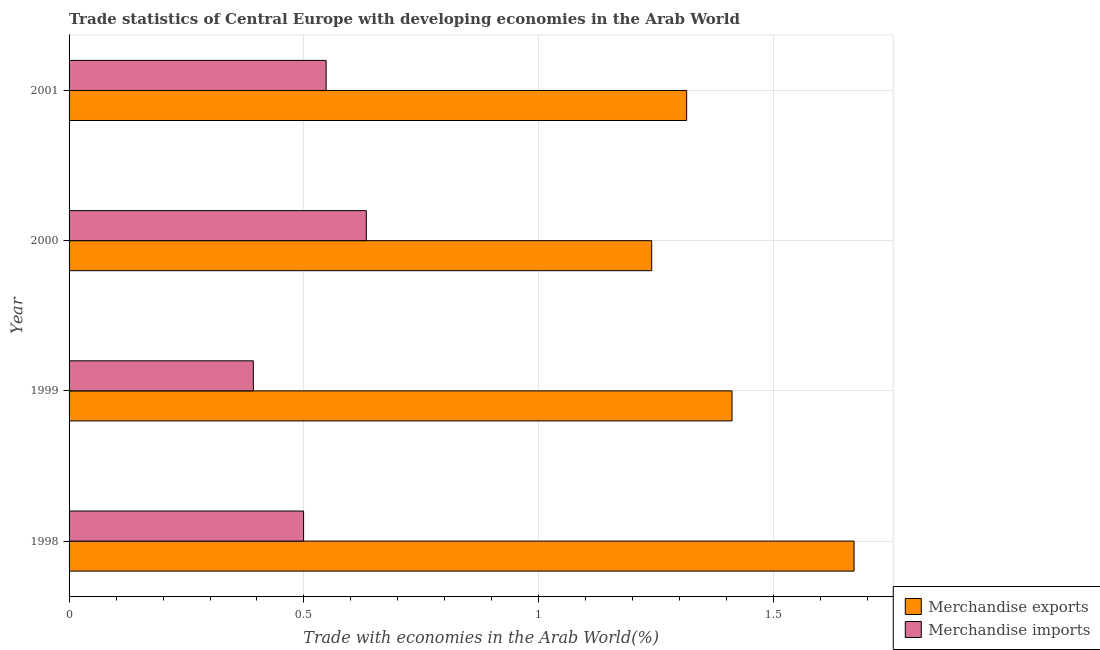How many different coloured bars are there?
Your answer should be very brief. 2. Are the number of bars per tick equal to the number of legend labels?
Offer a terse response. Yes. Are the number of bars on each tick of the Y-axis equal?
Give a very brief answer. Yes. How many bars are there on the 3rd tick from the bottom?
Provide a succinct answer. 2. In how many cases, is the number of bars for a given year not equal to the number of legend labels?
Offer a terse response. 0. What is the merchandise imports in 1998?
Give a very brief answer. 0.5. Across all years, what is the maximum merchandise exports?
Offer a terse response. 1.67. Across all years, what is the minimum merchandise imports?
Give a very brief answer. 0.39. What is the total merchandise imports in the graph?
Your answer should be compact. 2.07. What is the difference between the merchandise imports in 1998 and that in 2000?
Provide a succinct answer. -0.13. What is the difference between the merchandise imports in 1999 and the merchandise exports in 1998?
Provide a short and direct response. -1.28. What is the average merchandise exports per year?
Your response must be concise. 1.41. In the year 2001, what is the difference between the merchandise exports and merchandise imports?
Provide a short and direct response. 0.77. In how many years, is the merchandise exports greater than 1.2 %?
Keep it short and to the point. 4. What is the ratio of the merchandise exports in 1999 to that in 2000?
Your response must be concise. 1.14. Is the merchandise exports in 1998 less than that in 2001?
Provide a short and direct response. No. Is the difference between the merchandise imports in 1999 and 2001 greater than the difference between the merchandise exports in 1999 and 2001?
Your answer should be very brief. No. What is the difference between the highest and the second highest merchandise imports?
Provide a short and direct response. 0.09. What is the difference between the highest and the lowest merchandise exports?
Give a very brief answer. 0.43. Is the sum of the merchandise exports in 1999 and 2000 greater than the maximum merchandise imports across all years?
Keep it short and to the point. Yes. What does the 1st bar from the bottom in 2001 represents?
Offer a very short reply. Merchandise exports. Are all the bars in the graph horizontal?
Provide a short and direct response. Yes. Are the values on the major ticks of X-axis written in scientific E-notation?
Your answer should be very brief. No. Does the graph contain grids?
Give a very brief answer. Yes. How many legend labels are there?
Your answer should be compact. 2. How are the legend labels stacked?
Your answer should be compact. Vertical. What is the title of the graph?
Ensure brevity in your answer.  Trade statistics of Central Europe with developing economies in the Arab World. Does "RDB nonconcessional" appear as one of the legend labels in the graph?
Make the answer very short. No. What is the label or title of the X-axis?
Your response must be concise. Trade with economies in the Arab World(%). What is the label or title of the Y-axis?
Ensure brevity in your answer.  Year. What is the Trade with economies in the Arab World(%) in Merchandise exports in 1998?
Give a very brief answer. 1.67. What is the Trade with economies in the Arab World(%) in Merchandise imports in 1998?
Offer a terse response. 0.5. What is the Trade with economies in the Arab World(%) of Merchandise exports in 1999?
Keep it short and to the point. 1.41. What is the Trade with economies in the Arab World(%) in Merchandise imports in 1999?
Provide a succinct answer. 0.39. What is the Trade with economies in the Arab World(%) of Merchandise exports in 2000?
Provide a short and direct response. 1.24. What is the Trade with economies in the Arab World(%) of Merchandise imports in 2000?
Provide a succinct answer. 0.63. What is the Trade with economies in the Arab World(%) in Merchandise exports in 2001?
Offer a very short reply. 1.31. What is the Trade with economies in the Arab World(%) in Merchandise imports in 2001?
Your response must be concise. 0.55. Across all years, what is the maximum Trade with economies in the Arab World(%) in Merchandise exports?
Keep it short and to the point. 1.67. Across all years, what is the maximum Trade with economies in the Arab World(%) in Merchandise imports?
Offer a terse response. 0.63. Across all years, what is the minimum Trade with economies in the Arab World(%) of Merchandise exports?
Keep it short and to the point. 1.24. Across all years, what is the minimum Trade with economies in the Arab World(%) of Merchandise imports?
Offer a very short reply. 0.39. What is the total Trade with economies in the Arab World(%) of Merchandise exports in the graph?
Your answer should be very brief. 5.64. What is the total Trade with economies in the Arab World(%) in Merchandise imports in the graph?
Make the answer very short. 2.07. What is the difference between the Trade with economies in the Arab World(%) of Merchandise exports in 1998 and that in 1999?
Provide a succinct answer. 0.26. What is the difference between the Trade with economies in the Arab World(%) of Merchandise imports in 1998 and that in 1999?
Your response must be concise. 0.11. What is the difference between the Trade with economies in the Arab World(%) of Merchandise exports in 1998 and that in 2000?
Ensure brevity in your answer.  0.43. What is the difference between the Trade with economies in the Arab World(%) in Merchandise imports in 1998 and that in 2000?
Make the answer very short. -0.13. What is the difference between the Trade with economies in the Arab World(%) of Merchandise exports in 1998 and that in 2001?
Keep it short and to the point. 0.36. What is the difference between the Trade with economies in the Arab World(%) in Merchandise imports in 1998 and that in 2001?
Give a very brief answer. -0.05. What is the difference between the Trade with economies in the Arab World(%) of Merchandise exports in 1999 and that in 2000?
Provide a short and direct response. 0.17. What is the difference between the Trade with economies in the Arab World(%) of Merchandise imports in 1999 and that in 2000?
Provide a succinct answer. -0.24. What is the difference between the Trade with economies in the Arab World(%) of Merchandise exports in 1999 and that in 2001?
Provide a succinct answer. 0.1. What is the difference between the Trade with economies in the Arab World(%) in Merchandise imports in 1999 and that in 2001?
Your answer should be compact. -0.15. What is the difference between the Trade with economies in the Arab World(%) of Merchandise exports in 2000 and that in 2001?
Provide a succinct answer. -0.07. What is the difference between the Trade with economies in the Arab World(%) of Merchandise imports in 2000 and that in 2001?
Offer a terse response. 0.09. What is the difference between the Trade with economies in the Arab World(%) of Merchandise exports in 1998 and the Trade with economies in the Arab World(%) of Merchandise imports in 1999?
Provide a short and direct response. 1.28. What is the difference between the Trade with economies in the Arab World(%) in Merchandise exports in 1998 and the Trade with economies in the Arab World(%) in Merchandise imports in 2000?
Offer a terse response. 1.04. What is the difference between the Trade with economies in the Arab World(%) in Merchandise exports in 1998 and the Trade with economies in the Arab World(%) in Merchandise imports in 2001?
Your answer should be very brief. 1.12. What is the difference between the Trade with economies in the Arab World(%) in Merchandise exports in 1999 and the Trade with economies in the Arab World(%) in Merchandise imports in 2000?
Offer a very short reply. 0.78. What is the difference between the Trade with economies in the Arab World(%) in Merchandise exports in 1999 and the Trade with economies in the Arab World(%) in Merchandise imports in 2001?
Offer a terse response. 0.86. What is the difference between the Trade with economies in the Arab World(%) in Merchandise exports in 2000 and the Trade with economies in the Arab World(%) in Merchandise imports in 2001?
Your answer should be very brief. 0.69. What is the average Trade with economies in the Arab World(%) of Merchandise exports per year?
Provide a short and direct response. 1.41. What is the average Trade with economies in the Arab World(%) of Merchandise imports per year?
Offer a terse response. 0.52. In the year 1998, what is the difference between the Trade with economies in the Arab World(%) in Merchandise exports and Trade with economies in the Arab World(%) in Merchandise imports?
Make the answer very short. 1.17. In the year 1999, what is the difference between the Trade with economies in the Arab World(%) of Merchandise exports and Trade with economies in the Arab World(%) of Merchandise imports?
Provide a short and direct response. 1.02. In the year 2000, what is the difference between the Trade with economies in the Arab World(%) of Merchandise exports and Trade with economies in the Arab World(%) of Merchandise imports?
Provide a short and direct response. 0.61. In the year 2001, what is the difference between the Trade with economies in the Arab World(%) in Merchandise exports and Trade with economies in the Arab World(%) in Merchandise imports?
Offer a very short reply. 0.77. What is the ratio of the Trade with economies in the Arab World(%) of Merchandise exports in 1998 to that in 1999?
Offer a terse response. 1.18. What is the ratio of the Trade with economies in the Arab World(%) of Merchandise imports in 1998 to that in 1999?
Your response must be concise. 1.27. What is the ratio of the Trade with economies in the Arab World(%) of Merchandise exports in 1998 to that in 2000?
Your answer should be compact. 1.35. What is the ratio of the Trade with economies in the Arab World(%) in Merchandise imports in 1998 to that in 2000?
Offer a terse response. 0.79. What is the ratio of the Trade with economies in the Arab World(%) in Merchandise exports in 1998 to that in 2001?
Keep it short and to the point. 1.27. What is the ratio of the Trade with economies in the Arab World(%) in Merchandise imports in 1998 to that in 2001?
Provide a short and direct response. 0.91. What is the ratio of the Trade with economies in the Arab World(%) of Merchandise exports in 1999 to that in 2000?
Your response must be concise. 1.14. What is the ratio of the Trade with economies in the Arab World(%) of Merchandise imports in 1999 to that in 2000?
Offer a very short reply. 0.62. What is the ratio of the Trade with economies in the Arab World(%) in Merchandise exports in 1999 to that in 2001?
Your answer should be compact. 1.07. What is the ratio of the Trade with economies in the Arab World(%) in Merchandise imports in 1999 to that in 2001?
Your response must be concise. 0.72. What is the ratio of the Trade with economies in the Arab World(%) in Merchandise exports in 2000 to that in 2001?
Provide a short and direct response. 0.94. What is the ratio of the Trade with economies in the Arab World(%) in Merchandise imports in 2000 to that in 2001?
Make the answer very short. 1.16. What is the difference between the highest and the second highest Trade with economies in the Arab World(%) in Merchandise exports?
Offer a very short reply. 0.26. What is the difference between the highest and the second highest Trade with economies in the Arab World(%) of Merchandise imports?
Offer a terse response. 0.09. What is the difference between the highest and the lowest Trade with economies in the Arab World(%) of Merchandise exports?
Offer a terse response. 0.43. What is the difference between the highest and the lowest Trade with economies in the Arab World(%) of Merchandise imports?
Provide a succinct answer. 0.24. 